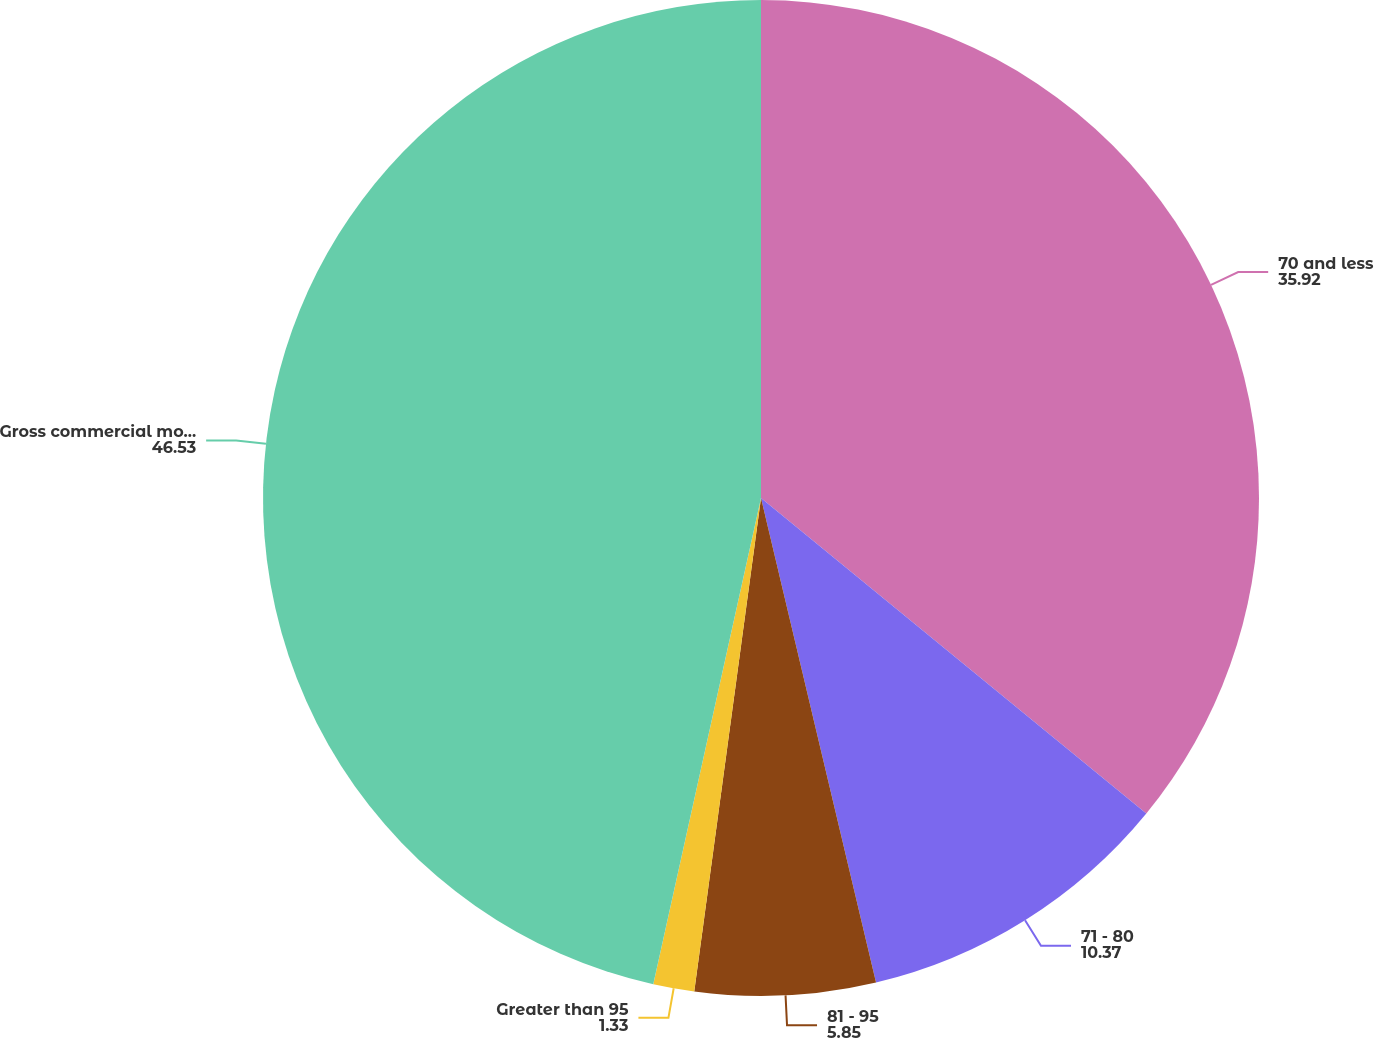Convert chart. <chart><loc_0><loc_0><loc_500><loc_500><pie_chart><fcel>70 and less<fcel>71 - 80<fcel>81 - 95<fcel>Greater than 95<fcel>Gross commercial mortgage<nl><fcel>35.92%<fcel>10.37%<fcel>5.85%<fcel>1.33%<fcel>46.53%<nl></chart> 